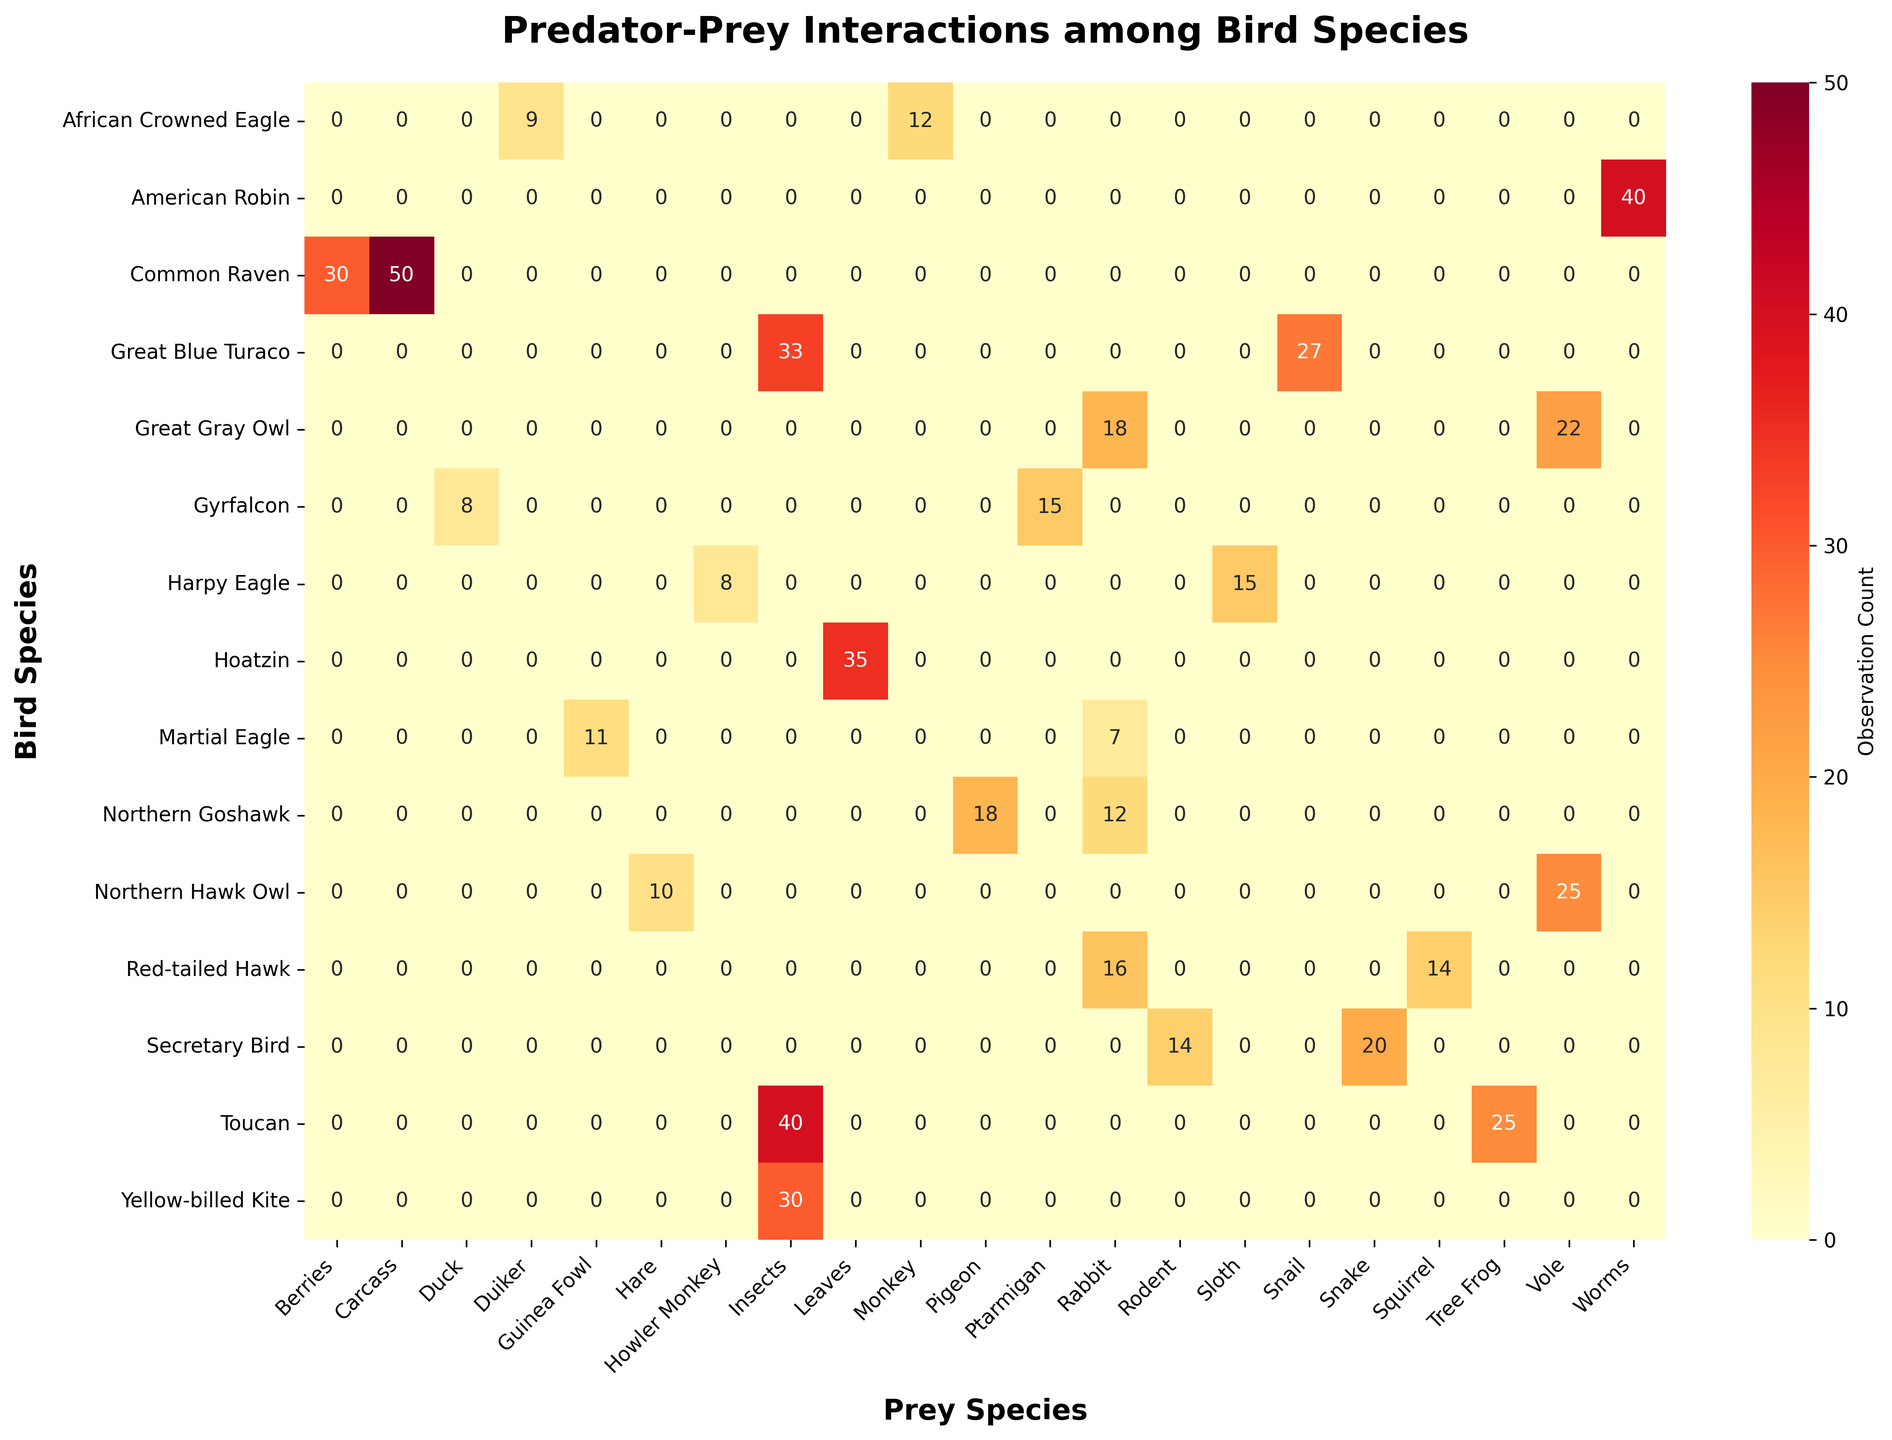Which bird species preys on Sloths in the Amazon Rainforest? To find the bird species that preys on Sloths in the Amazon Rainforest, locate the column for "Sloth" and observe the row corresponding to the Amazon Rainforest.
Answer: Harpy Eagle Which prey species has the highest observation count for the Toucan in the Amazon Rainforest? Locate the row for the Toucan species within the Amazon Rainforest section, then find the prey species with the highest count.
Answer: Insects What is the total observation count of the Martial Eagle's prey across all ecosystems? Add the counts for Guinea Fowl and Rabbit under the Martial Eagle row. The counts are 11 (Guinea Fowl) and 7 (Rabbit).
Answer: 18 Which ecosystem has the greatest variety of prey species? Count the number of prey species across ecosystems by observing the diversity of columns in each section. The ecosystem with the highest count is the one with the greatest variety.
Answer: Amazon Rainforest How does the observation count for the Secretary Bird preying on snakes in the Savannah compare to the Yellow-billed Kite preying on insects in the same ecosystem? Compare the observation count for the Secretary Bird and snakes, which is 20, with the count for the Yellow-billed Kite and insects, which is 30.
Answer: The Yellow-billed Kite preys on insects more frequently than the Secretary Bird preys on snakes Which prey species has the highest total observation count across all bird species? Sum the counts across all bird species for each prey species, then identify the species with the highest total. For example, sum the columns for all species and find the highest sum.
Answer: Insects What is the total number of prey species observed in the Boreal Forest? Count the unique prey species in the Boreal Forest section's columns. The prey species listed under Boreal Forest are "Vole", "Rabbit", "Carcass", and "Berries".
Answer: 4 Which bird species has the highest diversity of prey in the Boreal Forest? Identify the bird species in the Boreal Forest that preys on the greatest number of different prey species. Compare the number of prey species for each bird species.
Answer: Common Raven How many more prey species does the American Robin have compared to the Red-tailed Hawk in the Temperate Forest? Compare the number of prey species for American Robin and Red-tailed Hawk. American Robin has 1 species (Worms), and Red-tailed Hawk has 2 species (Squirrel, Rabbit).
Answer: 1 less Is the observation count for the Great Gray Owl preying on voles in the Boreal Forest higher or lower than the observation count for the African Crowned Eagle preying on monkeys in the African Rainforest? Compare the observation counts: 22 for Great Gray Owl on voles, 12 for African Crowned Eagle on monkeys.
Answer: Higher 